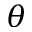Convert formula to latex. <formula><loc_0><loc_0><loc_500><loc_500>\theta</formula> 